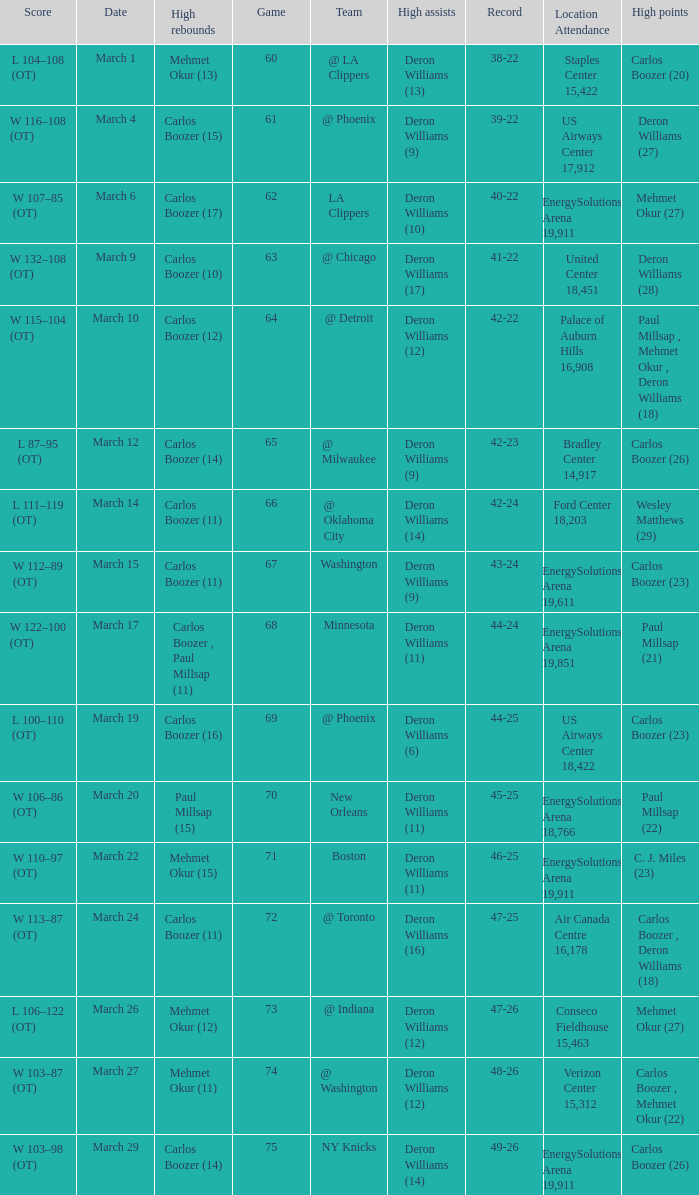Where was the March 24 game played? Air Canada Centre 16,178. 